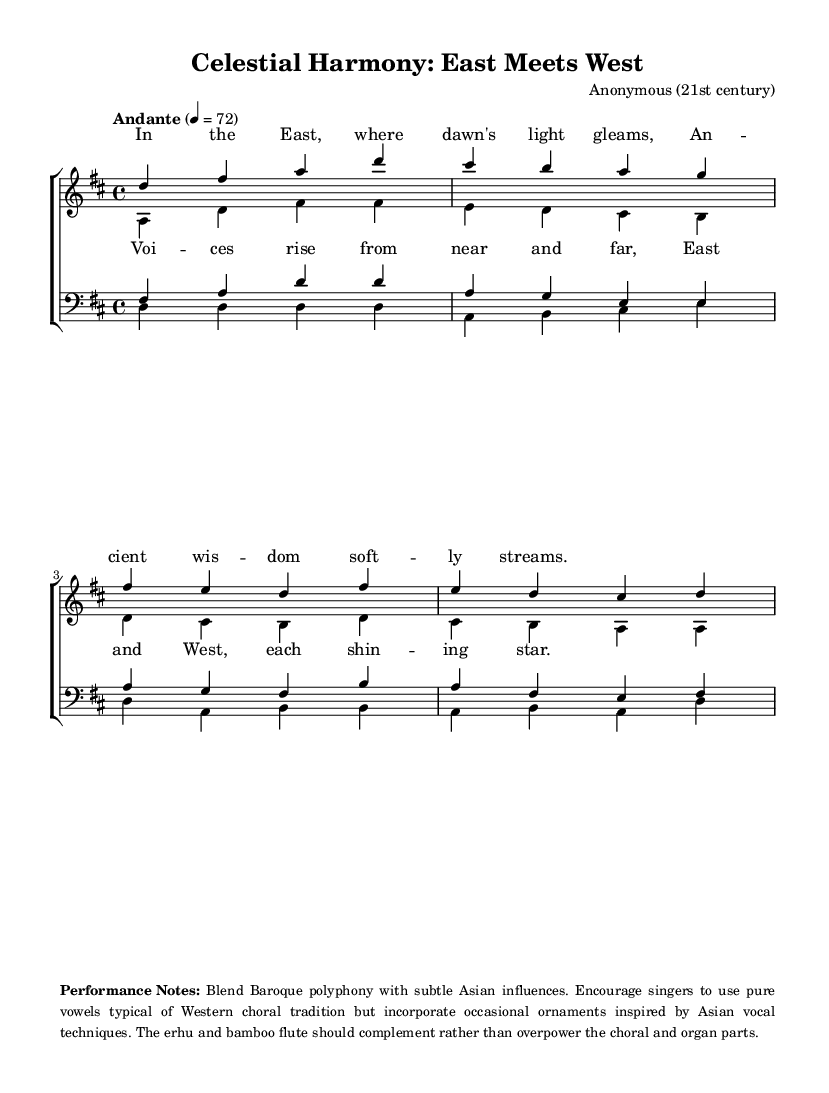What is the key signature of this music? The key signature is indicated by the number of sharps or flats at the beginning of the staff. In this case, there is two sharps, indicating D major.
Answer: D major What is the time signature of this piece? The time signature is shown as a fraction at the beginning of the music. Here, it is 4 over 4, meaning there are four beats per measure.
Answer: 4/4 What is the tempo marking for this music? The tempo marking is provided above the staff; it indicates how fast the piece should be played. The marking "Andante" signifies a moderate pace, and the numerical indication shows 72 beats per minute.
Answer: Andante How many voices are present in the choir? The music indicates multiple staves for different voice types. There are four distinct parts: sopranos, altos, tenors, and basses, totaling four voices.
Answer: Four voices What is the primary vocal texture used in this piece? The piece showcases a polyphonic texture typical of Baroque music, where multiple independent melody lines are sung simultaneously, especially through the interplay among the four vocal voices.
Answer: Polyphonic texture What type of instruments should complement the vocal parts according to the performance notes? The performance notes specify the inclusion of the erhu and bamboo flute to complement the choral and organ parts. Thus, these two instruments are highlighted for their role in supporting the vocal elements without overpowering them.
Answer: Erhu and bamboo flute 